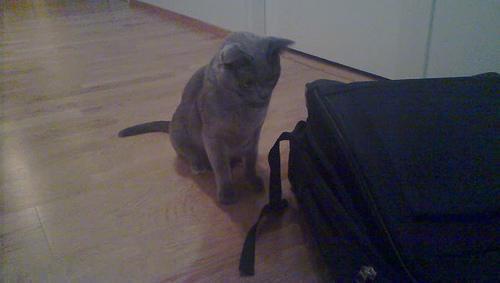How many cats in picture?
Give a very brief answer. 1. 